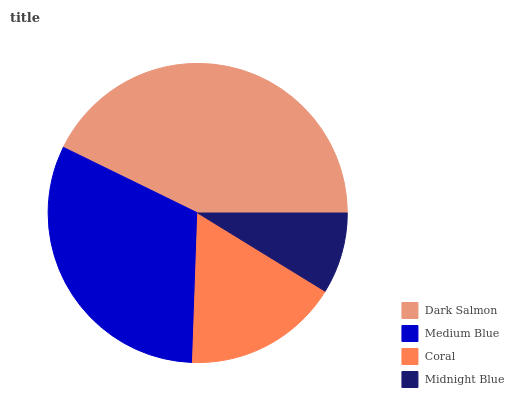Is Midnight Blue the minimum?
Answer yes or no. Yes. Is Dark Salmon the maximum?
Answer yes or no. Yes. Is Medium Blue the minimum?
Answer yes or no. No. Is Medium Blue the maximum?
Answer yes or no. No. Is Dark Salmon greater than Medium Blue?
Answer yes or no. Yes. Is Medium Blue less than Dark Salmon?
Answer yes or no. Yes. Is Medium Blue greater than Dark Salmon?
Answer yes or no. No. Is Dark Salmon less than Medium Blue?
Answer yes or no. No. Is Medium Blue the high median?
Answer yes or no. Yes. Is Coral the low median?
Answer yes or no. Yes. Is Coral the high median?
Answer yes or no. No. Is Dark Salmon the low median?
Answer yes or no. No. 